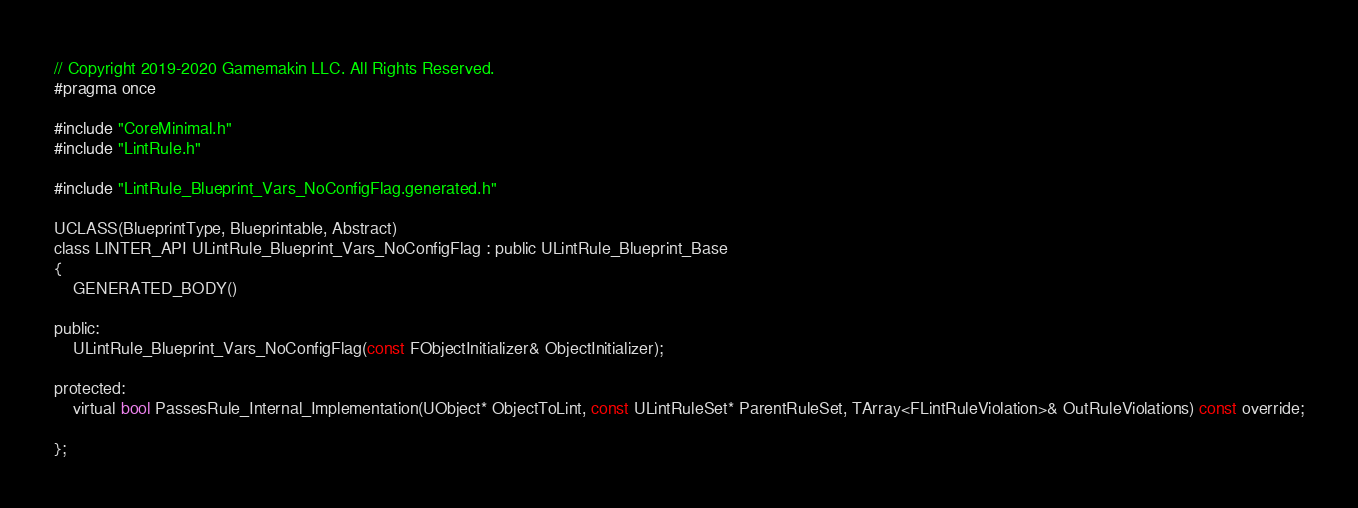Convert code to text. <code><loc_0><loc_0><loc_500><loc_500><_C_>// Copyright 2019-2020 Gamemakin LLC. All Rights Reserved.
#pragma once

#include "CoreMinimal.h"
#include "LintRule.h"

#include "LintRule_Blueprint_Vars_NoConfigFlag.generated.h"

UCLASS(BlueprintType, Blueprintable, Abstract)
class LINTER_API ULintRule_Blueprint_Vars_NoConfigFlag : public ULintRule_Blueprint_Base
{
	GENERATED_BODY()

public:
	ULintRule_Blueprint_Vars_NoConfigFlag(const FObjectInitializer& ObjectInitializer);

protected:
	virtual bool PassesRule_Internal_Implementation(UObject* ObjectToLint, const ULintRuleSet* ParentRuleSet, TArray<FLintRuleViolation>& OutRuleViolations) const override;

};
</code> 